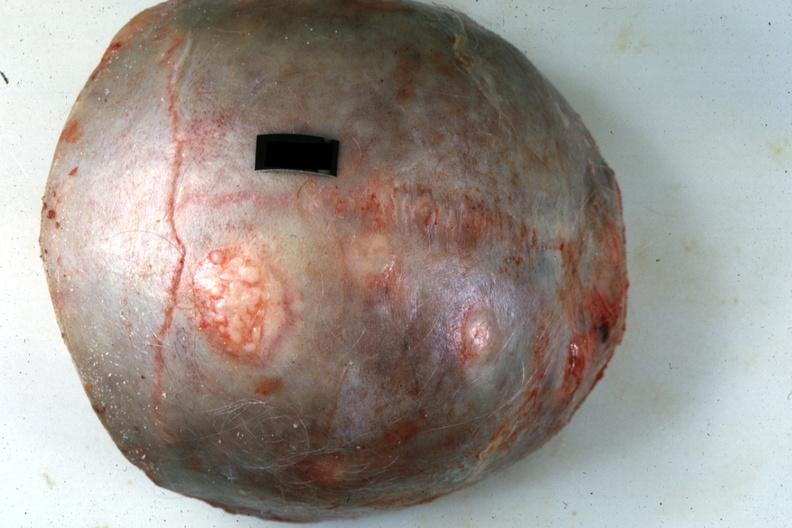does rheumatoid arthritis show skull cap with obvious metastatic lesions primary in pancreas?
Answer the question using a single word or phrase. No 